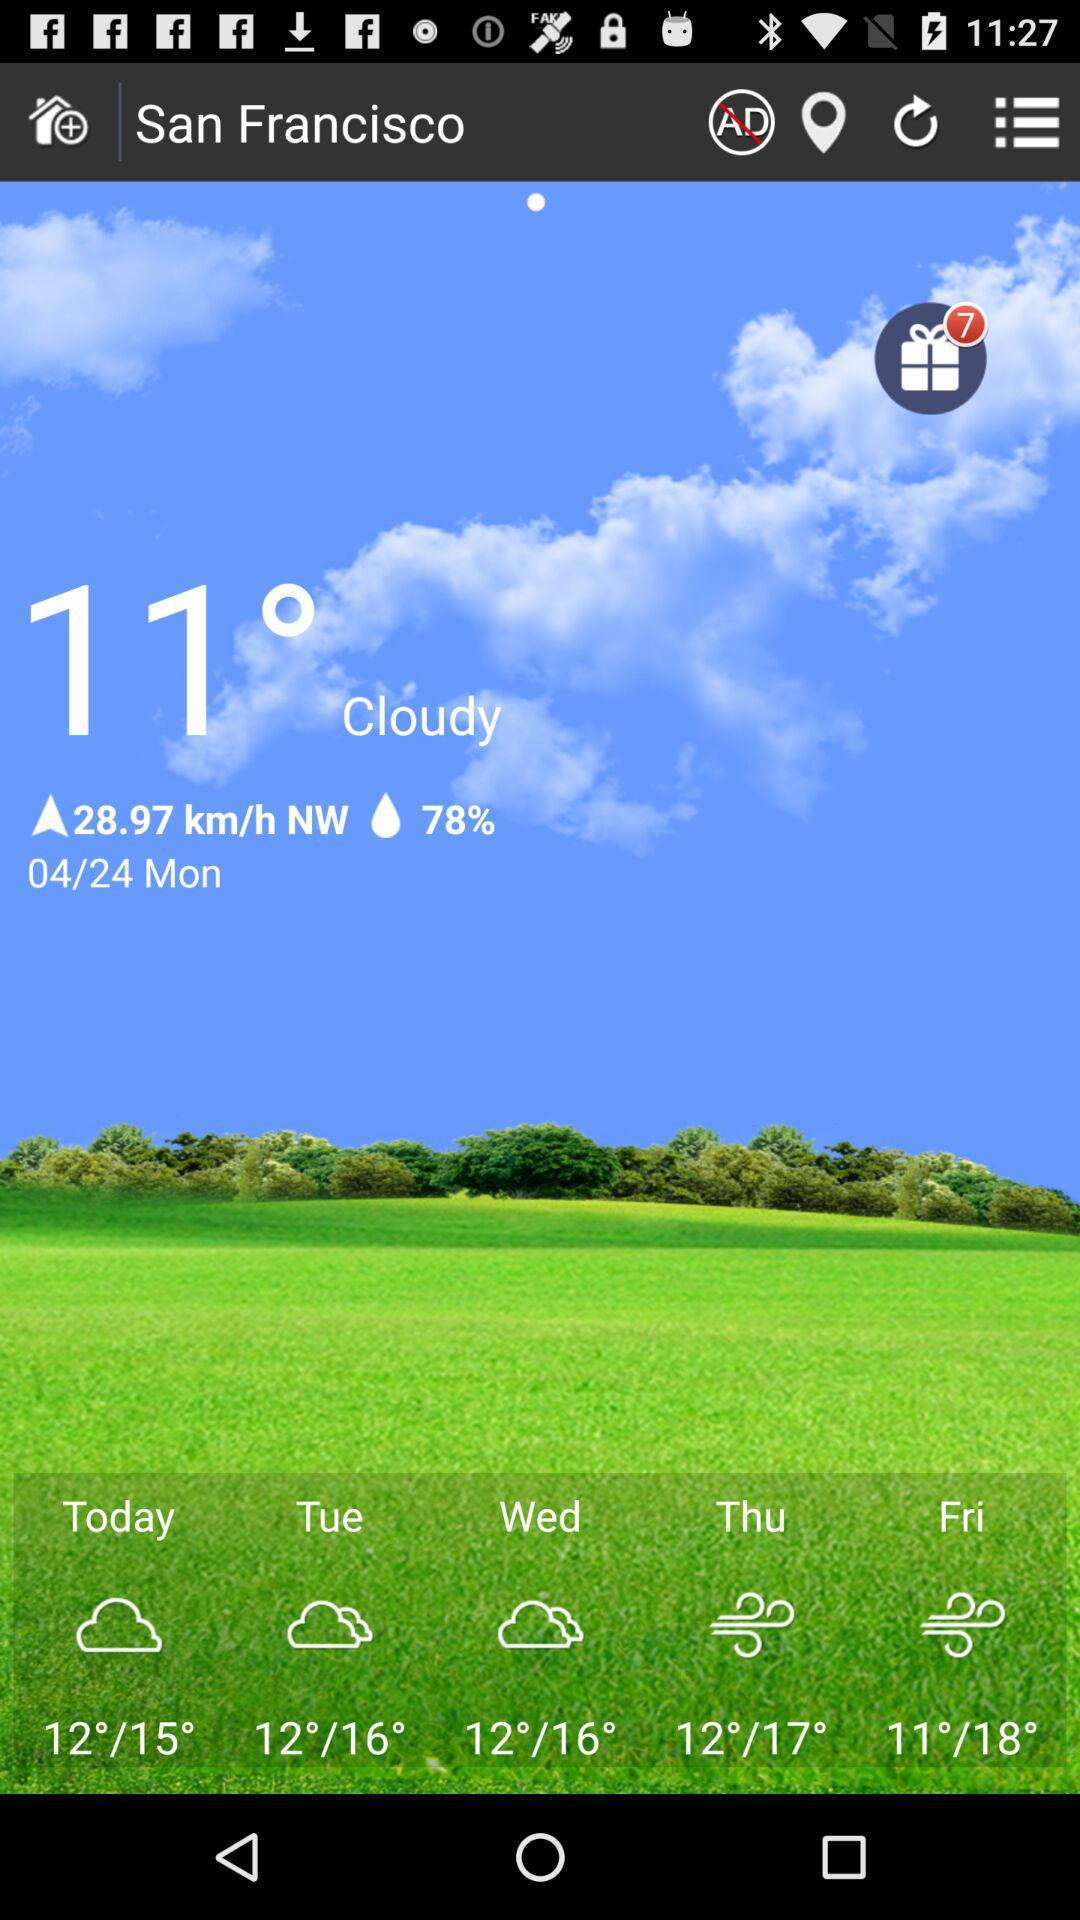What is the temperature on Tuesday?
When the provided information is insufficient, respond with <no answer>. <no answer> 